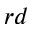Convert formula to latex. <formula><loc_0><loc_0><loc_500><loc_500>^ { r d }</formula> 